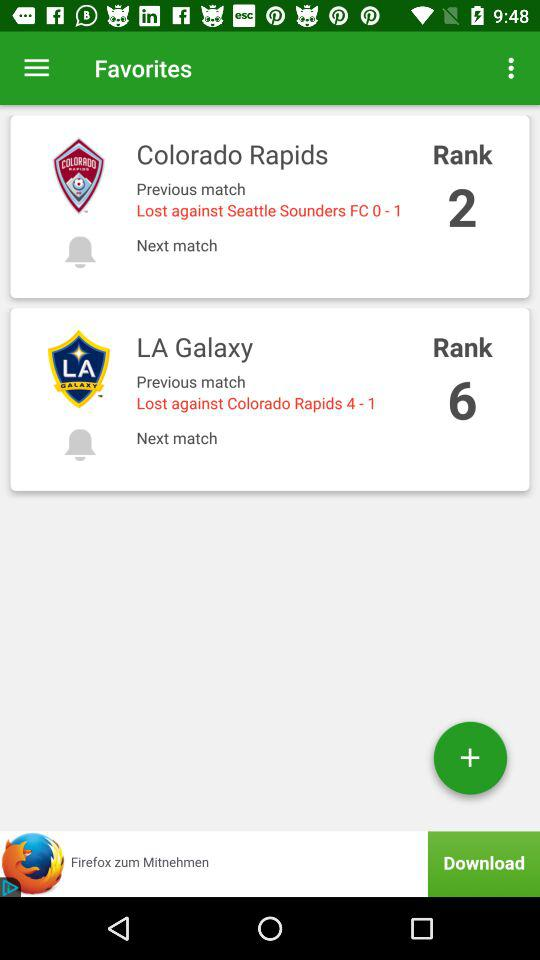By what score did the "LA Galaxy" lose the match against the "Colorado Rapids"? The "LA Galaxy" lost the match against the "Colorado Rapids" by 4-1. 